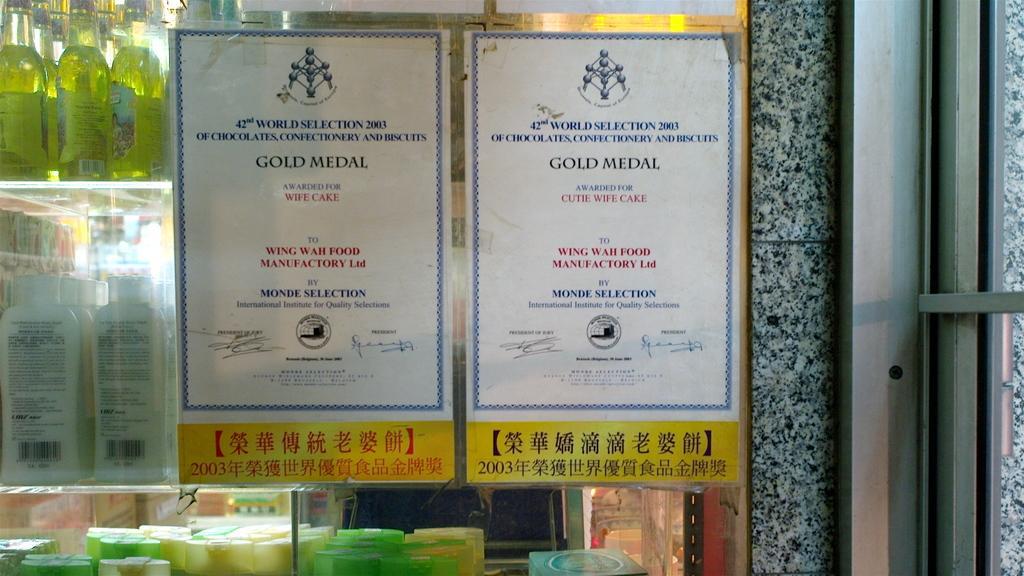Can you describe this image briefly? These are the papers attached to the glass door. I can see group of bottles placed in an order in the rack. This is a wall and this looks like an iron thing which is used to fix windows. 